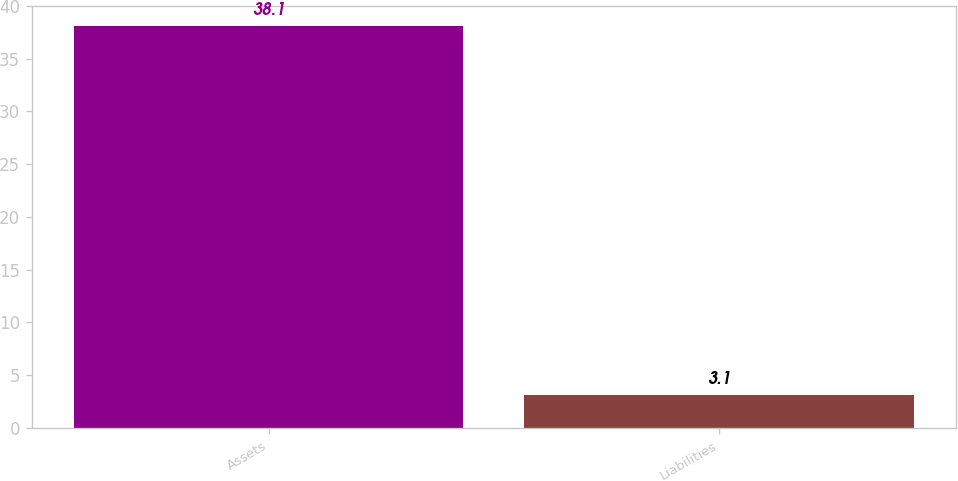Convert chart. <chart><loc_0><loc_0><loc_500><loc_500><bar_chart><fcel>Assets<fcel>Liabilities<nl><fcel>38.1<fcel>3.1<nl></chart> 